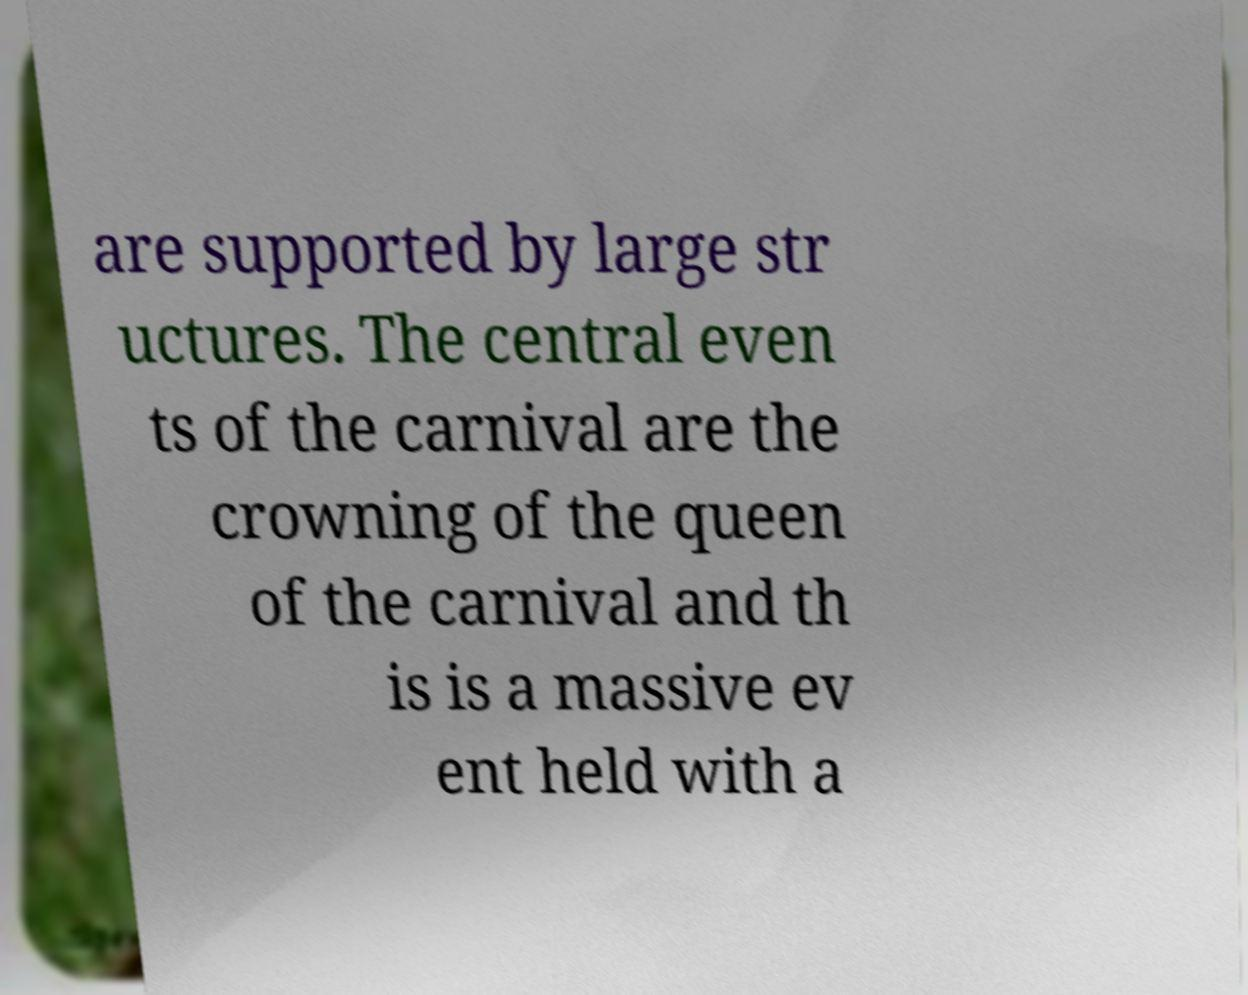I need the written content from this picture converted into text. Can you do that? are supported by large str uctures. The central even ts of the carnival are the crowning of the queen of the carnival and th is is a massive ev ent held with a 